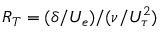Convert formula to latex. <formula><loc_0><loc_0><loc_500><loc_500>R _ { T } = ( \delta / U _ { e } ) / ( \nu / U _ { \tau } ^ { 2 } )</formula> 